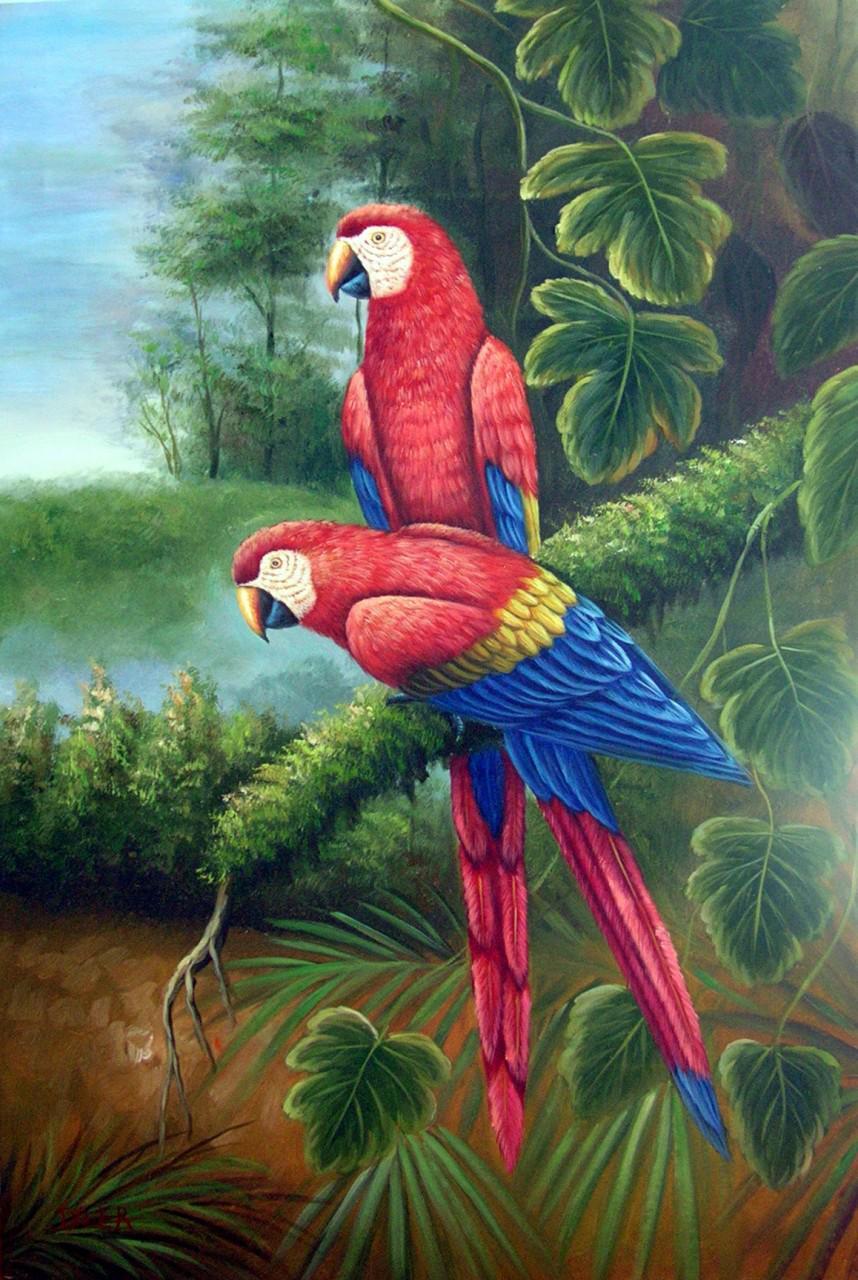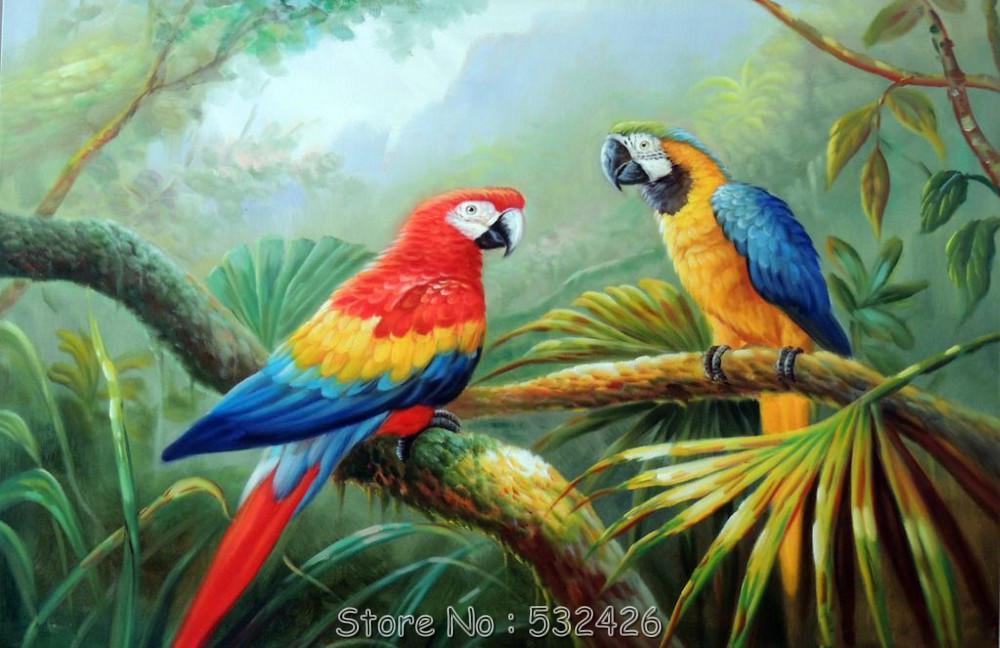The first image is the image on the left, the second image is the image on the right. Evaluate the accuracy of this statement regarding the images: "An image includes two colorful parrots in flight.". Is it true? Answer yes or no. No. 